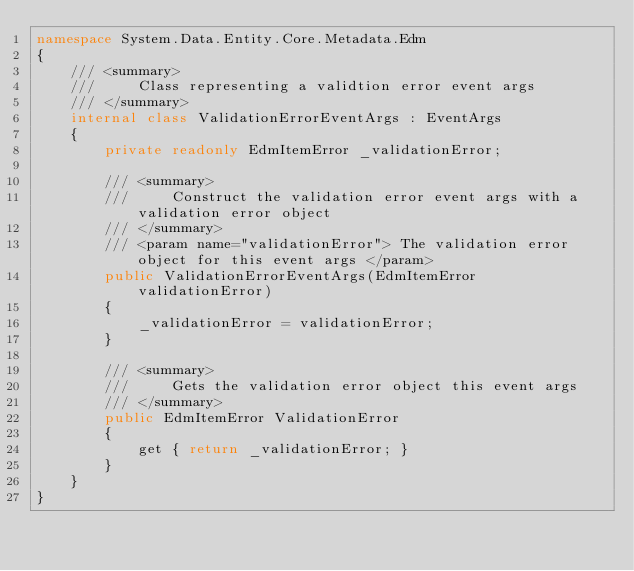Convert code to text. <code><loc_0><loc_0><loc_500><loc_500><_C#_>namespace System.Data.Entity.Core.Metadata.Edm
{
    /// <summary>
    ///     Class representing a validtion error event args
    /// </summary>
    internal class ValidationErrorEventArgs : EventArgs
    {
        private readonly EdmItemError _validationError;

        /// <summary>
        ///     Construct the validation error event args with a validation error object
        /// </summary>
        /// <param name="validationError"> The validation error object for this event args </param>
        public ValidationErrorEventArgs(EdmItemError validationError)
        {
            _validationError = validationError;
        }

        /// <summary>
        ///     Gets the validation error object this event args
        /// </summary>
        public EdmItemError ValidationError
        {
            get { return _validationError; }
        }
    }
}
</code> 